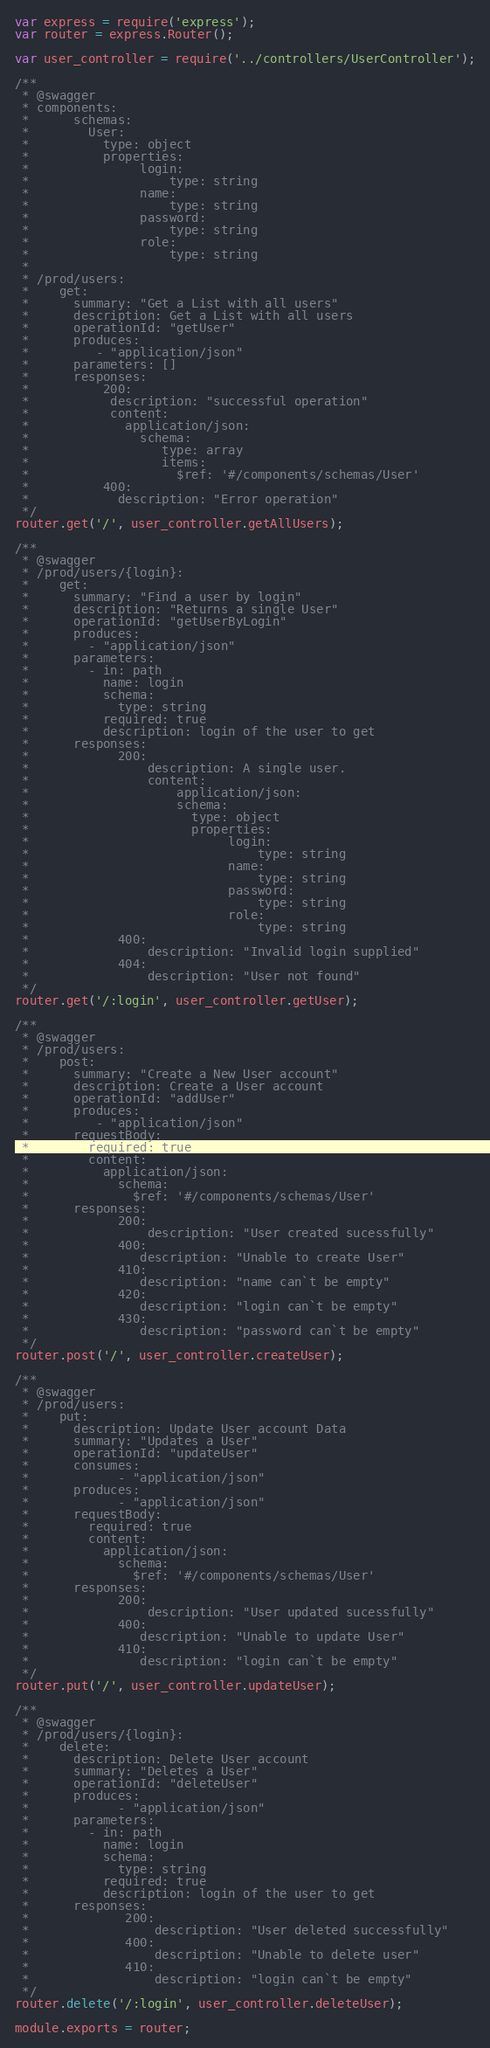Convert code to text. <code><loc_0><loc_0><loc_500><loc_500><_JavaScript_>var express = require('express');
var router = express.Router();

var user_controller = require('../controllers/UserController');

/**
 * @swagger
 * components:
 *      schemas:
 *        User:
 *          type: object
 *          properties:
 *               login:
 *                   type: string
 *               name:
 *                   type: string
 *               password:
 *                   type: string
 *               role:
 *                   type: string
 * 
 * /prod/users:
 *    get:
 *      summary: "Get a List with all users"
 *      description: Get a List with all users
 *      operationId: "getUser"
 *      produces:
 *         - "application/json"
 *      parameters: []
 *      responses:
 *          200:
 *           description: "successful operation"
 *           content:
 *             application/json:
 *               schema:
 *                  type: array
 *                  items:
 *                    $ref: '#/components/schemas/User'
 *          400:
 *            description: "Error operation" 
 */
router.get('/', user_controller.getAllUsers);

/**
 * @swagger
 * /prod/users/{login}:
 *    get:
 *      summary: "Find a user by login"
 *      description: "Returns a single User"
 *      operationId: "getUserByLogin"
 *      produces:
 *        - "application/json"
 *      parameters:
 *        - in: path
 *          name: login
 *          schema:
 *            type: string
 *          required: true
 *          description: login of the user to get
 *      responses:
 *            200:
 *                description: A single user.
 *                content:
 *                    application/json:
 *                    schema:
 *                      type: object
 *                      properties:
 *                           login:
 *                               type: string
 *                           name:
 *                               type: string
 *                           password:
 *                               type: string
 *                           role:
 *                               type: string
 *            400:
 *                description: "Invalid login supplied"
 *            404:
 *                description: "User not found"
 */
router.get('/:login', user_controller.getUser);

/**
 * @swagger
 * /prod/users:
 *    post:
 *      summary: "Create a New User account"
 *      description: Create a User account
 *      operationId: "addUser"
 *      produces:
 *         - "application/json"
 *      requestBody:
 *        required: true
 *        content:
 *          application/json:
 *            schema:
 *              $ref: '#/components/schemas/User'
 *      responses:
 *            200:
 *                description: "User created sucessfully"
 *            400:
 *               description: "Unable to create User"
 *            410:
 *               description: "name can`t be empty"
 *            420:
 *               description: "login can`t be empty"
 *            430:
 *               description: "password can`t be empty"
 */
router.post('/', user_controller.createUser);

/**
 * @swagger
 * /prod/users:
 *    put:
 *      description: Update User account Data
 *      summary: "Updates a User"
 *      operationId: "updateUser"
 *      consumes:
 *            - "application/json"
 *      produces:
 *            - "application/json"
 *      requestBody:
 *        required: true
 *        content:
 *          application/json:
 *            schema:
 *              $ref: '#/components/schemas/User'
 *      responses:
 *            200:
 *                description: "User updated sucessfully"
 *            400:
 *               description: "Unable to update User"
 *            410:
 *               description: "login can`t be empty"
 */
router.put('/', user_controller.updateUser);

/**
 * @swagger
 * /prod/users/{login}:
 *    delete:
 *      description: Delete User account
 *      summary: "Deletes a User"
 *      operationId: "deleteUser"
 *      produces:
 *            - "application/json"
 *      parameters:
 *        - in: path
 *          name: login
 *          schema:
 *            type: string
 *          required: true
 *          description: login of the user to get
 *      responses:
 *             200:
 *                 description: "User deleted successfully" 
 *             400:
 *                 description: "Unable to delete user"
 *             410:
 *                 description: "login can`t be empty"
 */
router.delete('/:login', user_controller.deleteUser);

module.exports = router;
</code> 